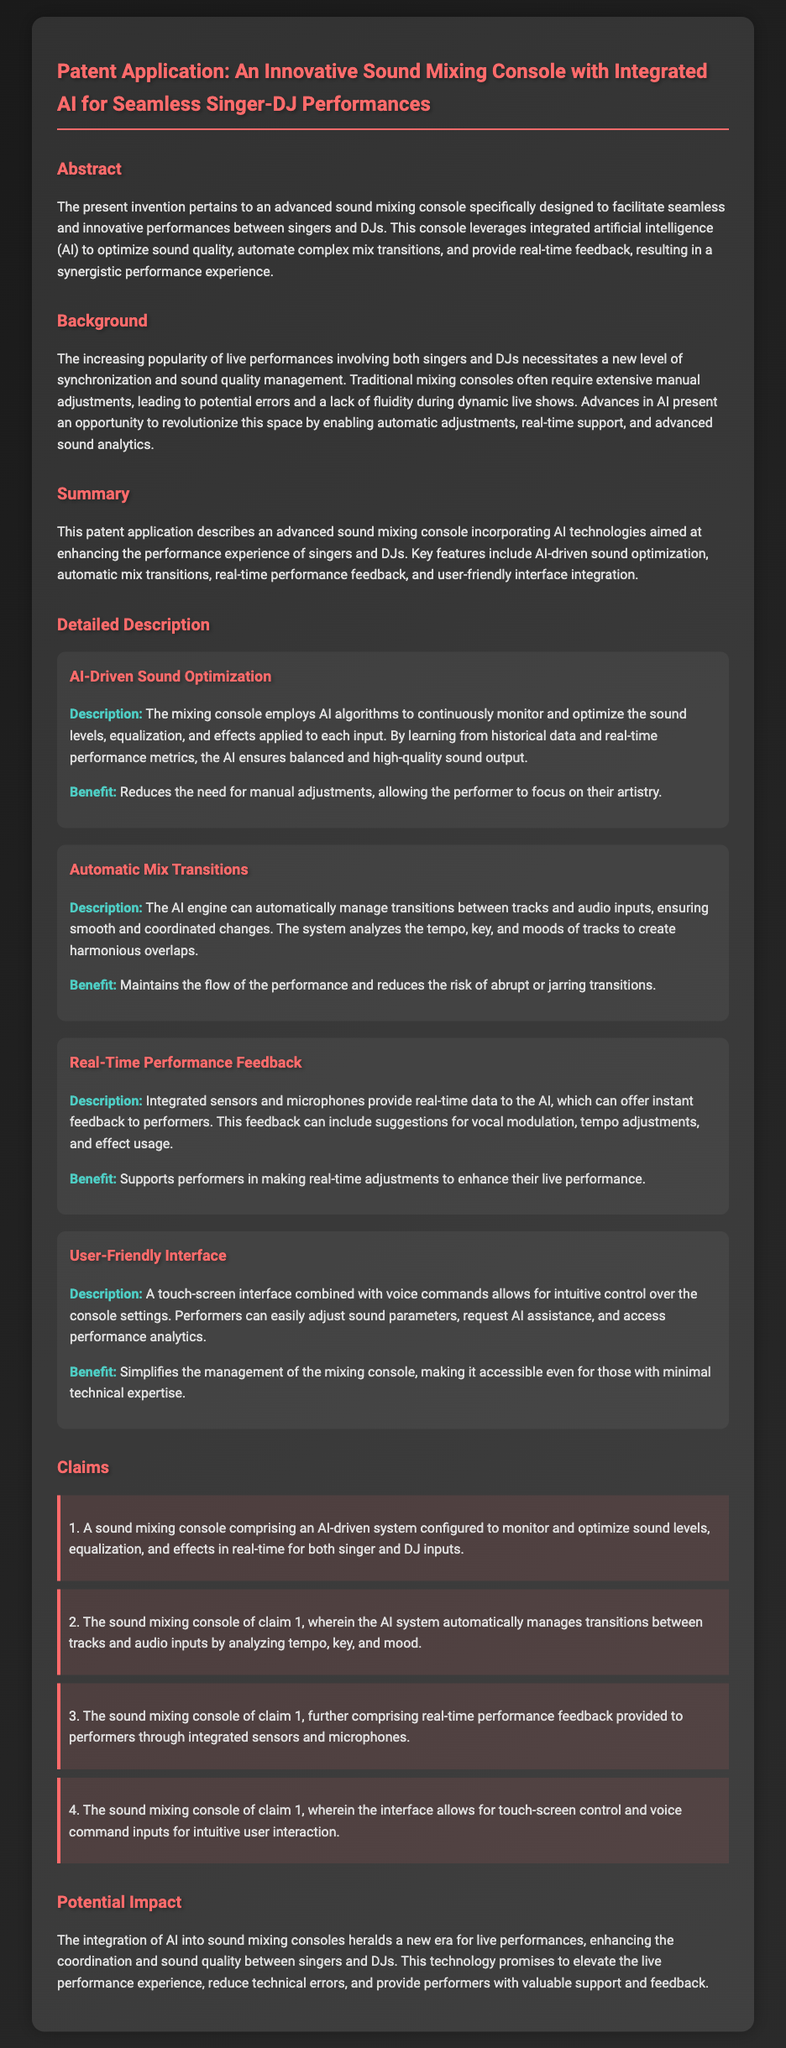What does the invention pertain to? The invention pertains to an advanced sound mixing console specifically designed to facilitate seamless and innovative performances between singers and DJs.
Answer: sound mixing console What technology does the console leverage? The console leverages integrated artificial intelligence (AI) to optimize sound quality.
Answer: artificial intelligence What is a benefit of AI-driven sound optimization? AI-driven sound optimization reduces the need for manual adjustments, allowing the performer to focus on their artistry.
Answer: reduces manual adjustments How many claims are listed in the document? There are four claims listed in the document regarding the features of the sound mixing console.
Answer: four What is the purpose of the real-time performance feedback? Real-time performance feedback is intended to support performers in making real-time adjustments to enhance their live performance.
Answer: support performers What kind of interface does the mixing console feature? The mixing console features a touch-screen interface combined with voice commands for control.
Answer: touch-screen interface What does the AI engine manage according to claim 2? According to claim 2, the AI engine manages transitions between tracks and audio inputs.
Answer: transitions between tracks What is the potential impact mentioned in the document? The potential impact mentioned includes enhancing coordination and sound quality between singers and DJs.
Answer: enhancing coordination and sound quality 